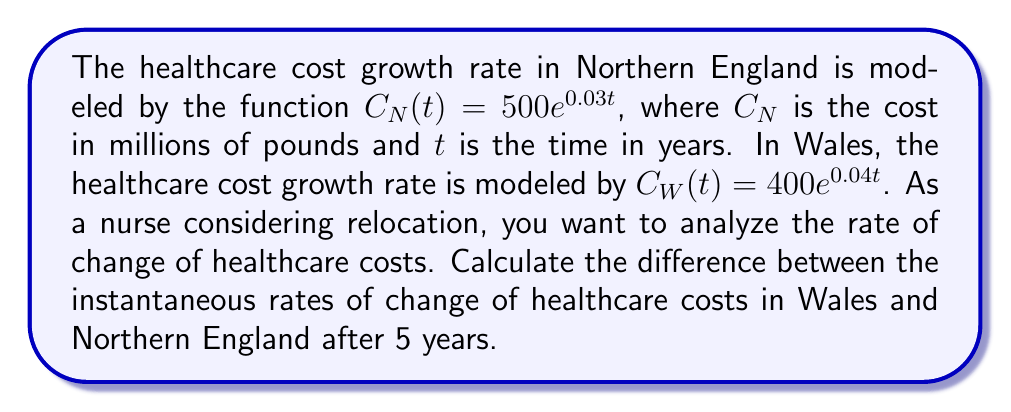Help me with this question. To solve this problem, we need to follow these steps:

1. Find the derivative of each function to get the rate of change:
   For Northern England: $C_N'(t) = \frac{d}{dt}(500e^{0.03t}) = 500 \cdot 0.03e^{0.03t} = 15e^{0.03t}$
   For Wales: $C_W'(t) = \frac{d}{dt}(400e^{0.04t}) = 400 \cdot 0.04e^{0.04t} = 16e^{0.04t}$

2. Evaluate each derivative at $t = 5$:
   For Northern England: $C_N'(5) = 15e^{0.03 \cdot 5} = 15e^{0.15} \approx 17.39$ million pounds per year
   For Wales: $C_W'(5) = 16e^{0.04 \cdot 5} = 16e^{0.20} \approx 19.53$ million pounds per year

3. Calculate the difference between the rates:
   Difference = $C_W'(5) - C_N'(5) = 19.53 - 17.39 = 2.14$ million pounds per year
Answer: $2.14$ million pounds per year 